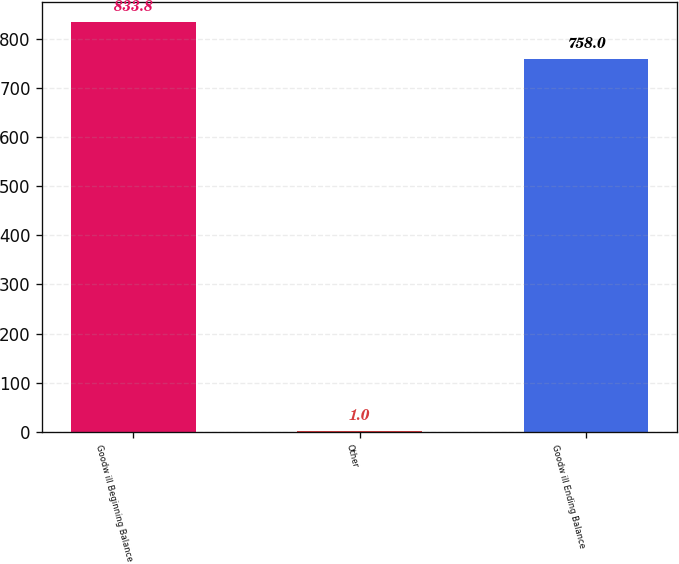Convert chart. <chart><loc_0><loc_0><loc_500><loc_500><bar_chart><fcel>Goodw ill Beginning Balance<fcel>Other<fcel>Goodw ill Ending Balance<nl><fcel>833.8<fcel>1<fcel>758<nl></chart> 